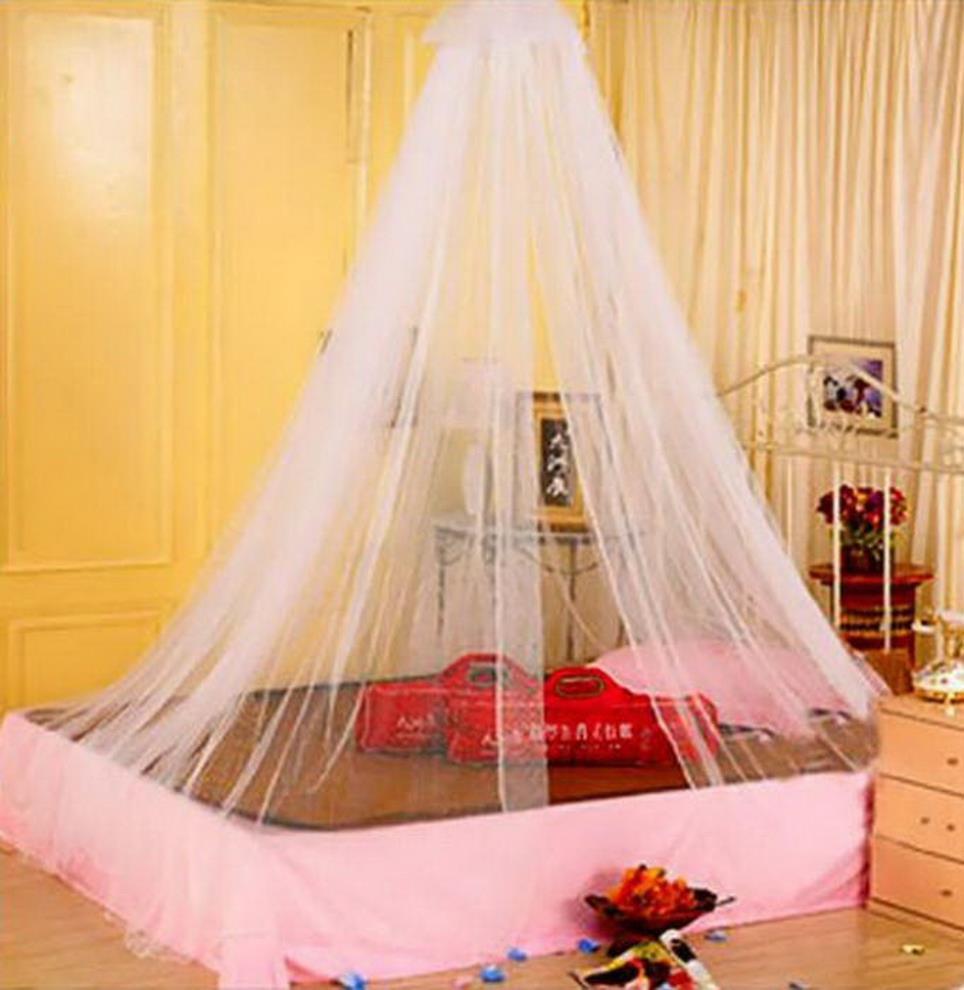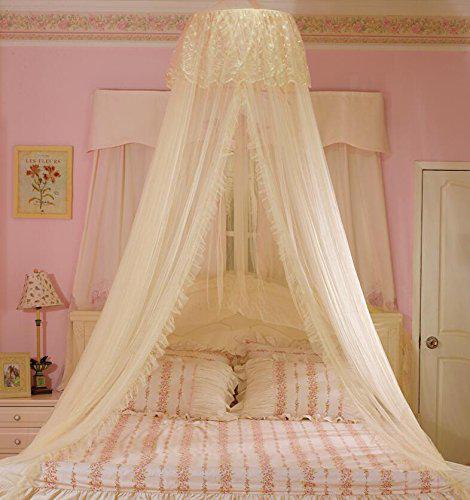The first image is the image on the left, the second image is the image on the right. Considering the images on both sides, is "The left and right image contains the same number of canopies one square and one circle." valid? Answer yes or no. No. 